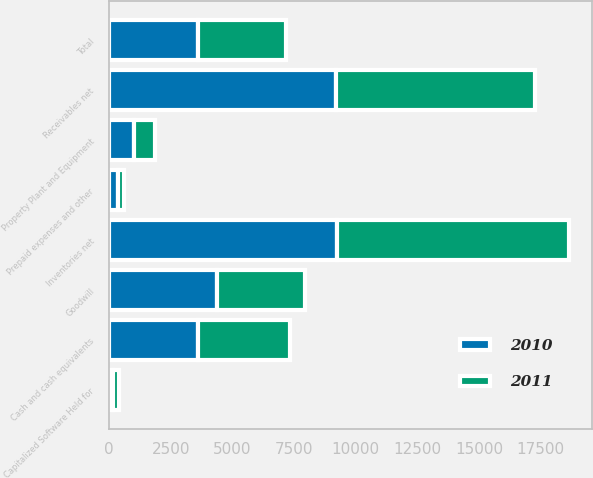Convert chart. <chart><loc_0><loc_0><loc_500><loc_500><stacked_bar_chart><ecel><fcel>Cash and cash equivalents<fcel>Receivables net<fcel>Inventories net<fcel>Prepaid expenses and other<fcel>Total<fcel>Property Plant and Equipment<fcel>Capitalized Software Held for<fcel>Goodwill<nl><fcel>2010<fcel>3612<fcel>9187<fcel>9225<fcel>333<fcel>3590<fcel>991<fcel>152<fcel>4364<nl><fcel>2011<fcel>3731<fcel>8075<fcel>9441<fcel>257<fcel>3590<fcel>851<fcel>234<fcel>3568<nl></chart> 